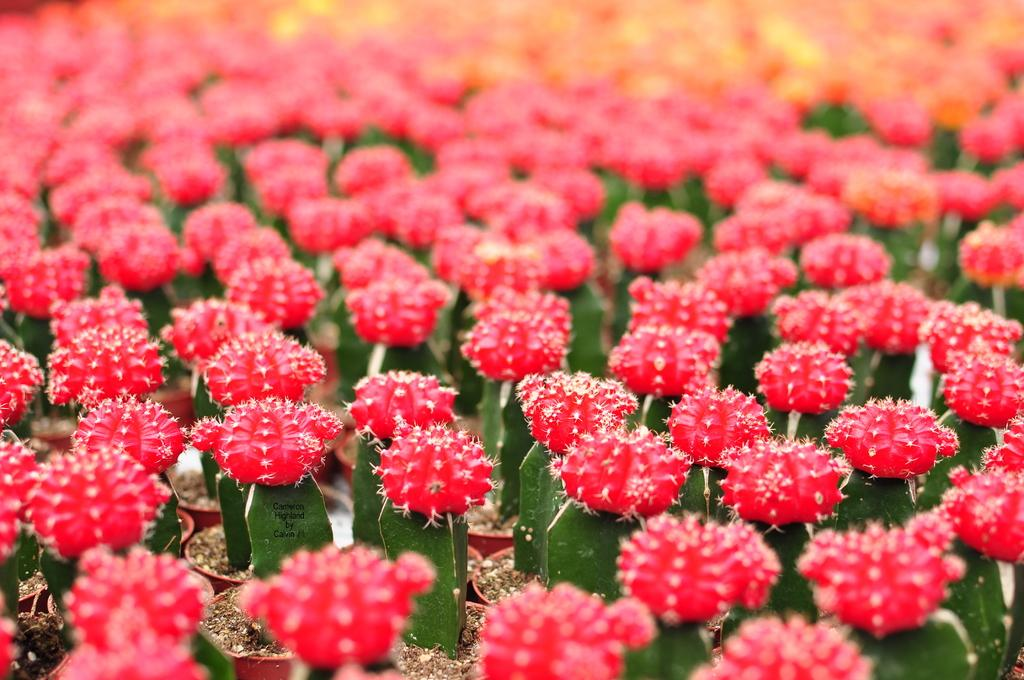Where was the image taken? The image was taken outdoors. What type of plants can be seen in the image? There are cactus plants in the image. What color are the flowers on the cactus plants? The flowers on the cactus plants are pink. How are the cactus plants arranged in the image? The cactus plants are in pots. What type of legal advice is the cactus plant providing in the image? There is no lawyer or legal advice present in the image; it features cactus plants with pink flowers in pots. 